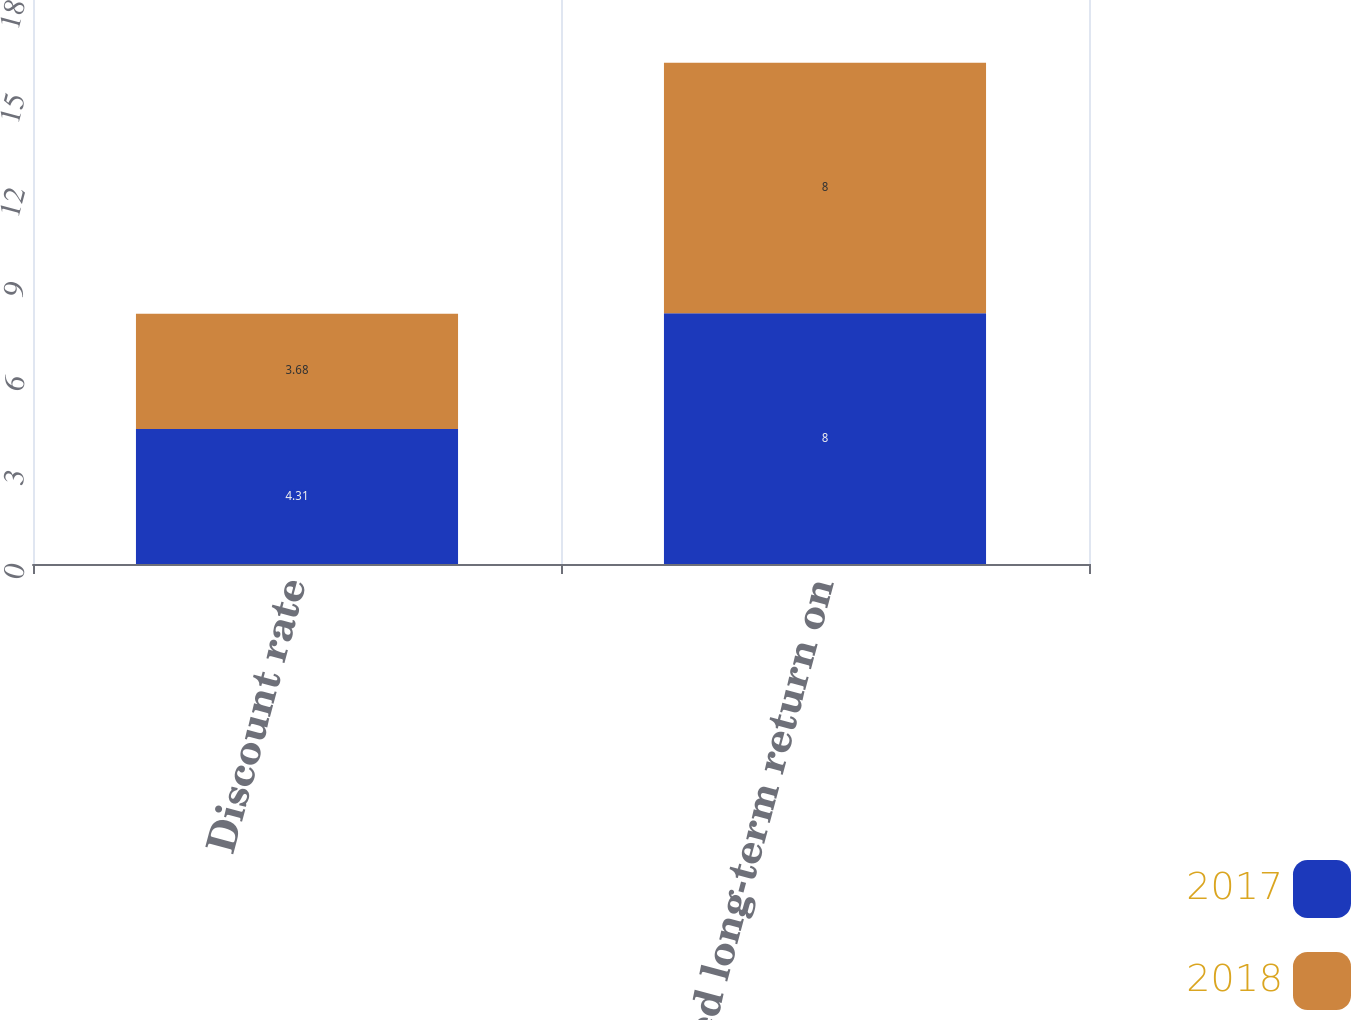<chart> <loc_0><loc_0><loc_500><loc_500><stacked_bar_chart><ecel><fcel>Discount rate<fcel>Expected long-term return on<nl><fcel>2017<fcel>4.31<fcel>8<nl><fcel>2018<fcel>3.68<fcel>8<nl></chart> 